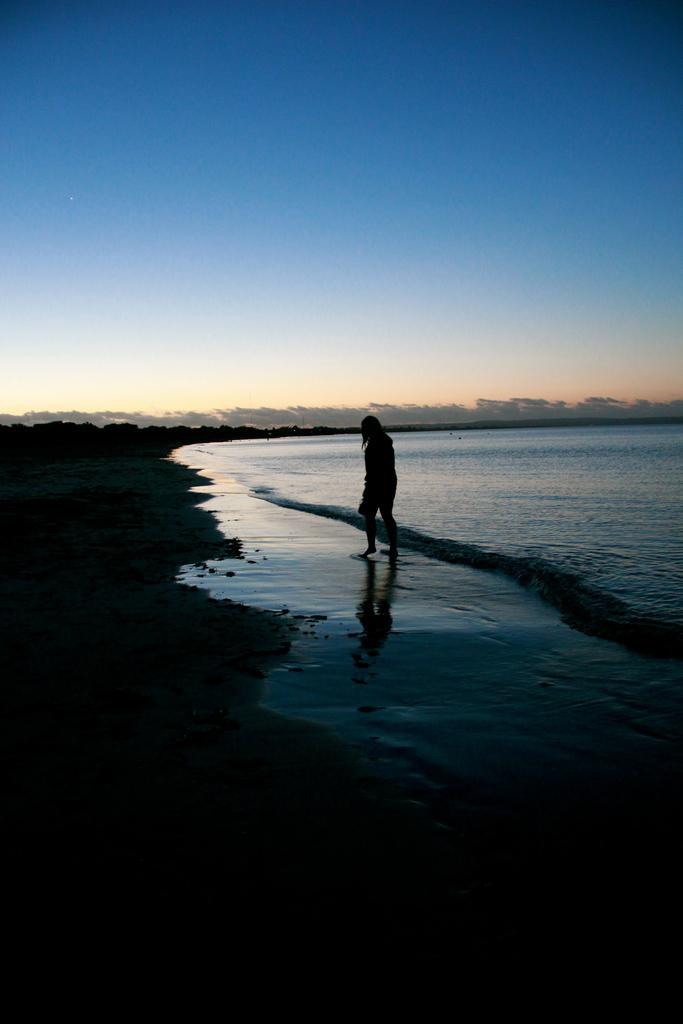Please provide a concise description of this image. In this picture we can see a person is walking on the path. In front of the person there is water and the sky. 